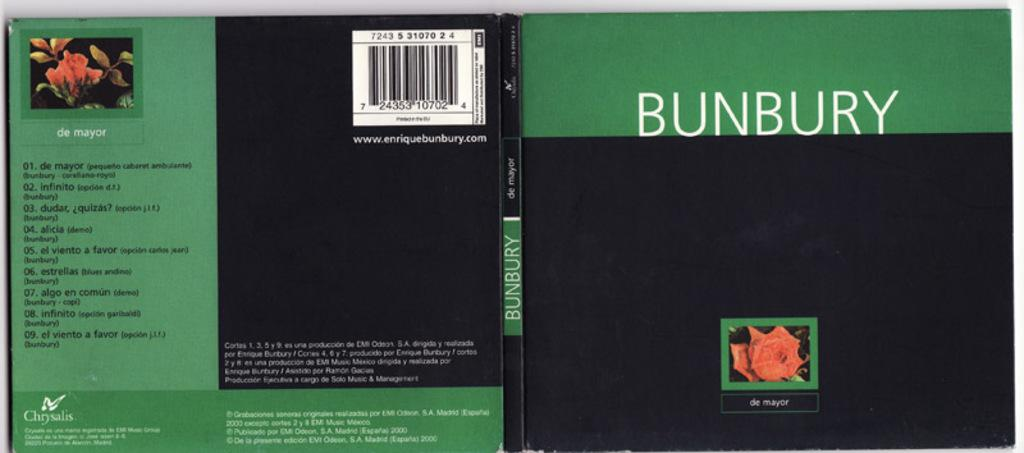<image>
Relay a brief, clear account of the picture shown. A book entitiled "Bunbury" has a picture of a rose on it. 